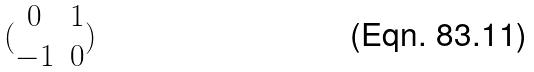<formula> <loc_0><loc_0><loc_500><loc_500>( \begin{matrix} 0 & 1 \\ - 1 & 0 \end{matrix} )</formula> 